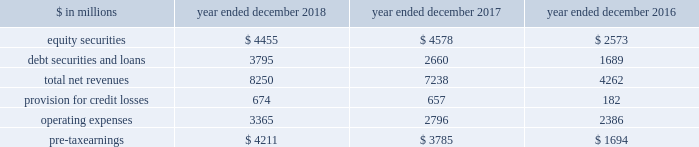The goldman sachs group , inc .
And subsidiaries management 2019s discussion and analysis net revenues in equities were $ 6.60 billion , 4% ( 4 % ) lower than 2016 , primarily due to lower commissions and fees , reflecting a decline in our listed cash equity volumes in the u.s .
Market volumes in the u.s .
Also declined .
In addition , net revenues in equities client execution were lower , reflecting lower net revenues in derivatives , partially offset by higher net revenues in cash products .
Net revenues in securities services were essentially unchanged .
Operating expenses were $ 9.69 billion for 2017 , essentially unchanged compared with 2016 , due to decreased compensation and benefits expenses , reflecting lower net revenues , largely offset by increased technology expenses , reflecting higher expenses related to cloud-based services and software depreciation , and increased consulting costs .
Pre-tax earnings were $ 2.21 billion in 2017 , 54% ( 54 % ) lower than 2016 .
Investing & lending investing & lending includes our investing activities and the origination of loans , including our relationship lending activities , to provide financing to clients .
These investments and loans are typically longer-term in nature .
We make investments , some of which are consolidated , including through our merchant banking business and our special situations group , in debt securities and loans , public and private equity securities , infrastructure and real estate entities .
Some of these investments are made indirectly through funds that we manage .
We also make unsecured loans through our digital platform , marcus : by goldman sachs and secured loans through our digital platform , goldman sachs private bank select .
The table below presents the operating results of our investing & lending segment. .
Operating environment .
During 2018 , our investments in private equities benefited from company-specific events , including sales , and strong corporate performance , while investments in public equities reflected losses , as global equity prices generally decreased .
Results for our investments in debt securities and loans reflected continued growth in loans receivables , resulting in higher net interest income .
If macroeconomic concerns negatively affect corporate performance or the origination of loans , or if global equity prices continue to decline , net revenues in investing & lending would likely be negatively impacted .
During 2017 , generally higher global equity prices and tighter credit spreads contributed to a favorable environment for our equity and debt investments .
Results also reflected net gains from company-specific events , including sales , and corporate performance .
2018 versus 2017 .
Net revenues in investing & lending were $ 8.25 billion for 2018 , 14% ( 14 % ) higher than 2017 .
Net revenues in equity securities were $ 4.46 billion , 3% ( 3 % ) lower than 2017 , reflecting net losses from investments in public equities ( 2018 included $ 183 million of net losses ) compared with net gains in the prior year , partially offset by significantly higher net gains from investments in private equities ( 2018 included $ 4.64 billion of net gains ) , driven by company-specific events , including sales , and corporate performance .
For 2018 , 60% ( 60 % ) of the net revenues in equity securities were generated from corporate investments and 40% ( 40 % ) were generated from real estate .
Net revenues in debt securities and loans were $ 3.80 billion , 43% ( 43 % ) higher than 2017 , primarily driven by significantly higher net interest income .
2018 included net interest income of approximately $ 2.70 billion compared with approximately $ 1.80 billion in 2017 .
Provision for credit losses was $ 674 million for 2018 , compared with $ 657 million for 2017 , as the higher provision for credit losses primarily related to consumer loan growth in 2018 was partially offset by an impairment of approximately $ 130 million on a secured loan in 2017 .
Operating expenses were $ 3.37 billion for 2018 , 20% ( 20 % ) higher than 2017 , primarily due to increased expenses related to consolidated investments and our digital lending and deposit platform , and increased compensation and benefits expenses , reflecting higher net revenues .
Pre-tax earnings were $ 4.21 billion in 2018 , 11% ( 11 % ) higher than 2017 versus 2016 .
Net revenues in investing & lending were $ 7.24 billion for 2017 , 70% ( 70 % ) higher than 2016 .
Net revenues in equity securities were $ 4.58 billion , 78% ( 78 % ) higher than 2016 , primarily reflecting a significant increase in net gains from private equities ( 2017 included $ 3.82 billion of net gains ) , which were positively impacted by company-specific events and corporate performance .
In addition , net gains from public equities ( 2017 included $ 762 million of net gains ) were significantly higher , as global equity prices increased during the year .
For 2017 , 64% ( 64 % ) of the net revenues in equity securities were generated from corporate investments and 36% ( 36 % ) were generated from real estate .
Net revenues in debt securities and loans were $ 2.66 billion , 57% ( 57 % ) higher than 2016 , reflecting significantly higher net interest income ( 2017 included approximately $ 1.80 billion of net interest income ) .
60 goldman sachs 2018 form 10-k .
For the lending segment , in millions , for 2018 , 2017 , and 2016 , what was the largest earnings from equity securities? 
Computations: table_max(equity securities, none)
Answer: 4578.0. The goldman sachs group , inc .
And subsidiaries management 2019s discussion and analysis net revenues in equities were $ 6.60 billion , 4% ( 4 % ) lower than 2016 , primarily due to lower commissions and fees , reflecting a decline in our listed cash equity volumes in the u.s .
Market volumes in the u.s .
Also declined .
In addition , net revenues in equities client execution were lower , reflecting lower net revenues in derivatives , partially offset by higher net revenues in cash products .
Net revenues in securities services were essentially unchanged .
Operating expenses were $ 9.69 billion for 2017 , essentially unchanged compared with 2016 , due to decreased compensation and benefits expenses , reflecting lower net revenues , largely offset by increased technology expenses , reflecting higher expenses related to cloud-based services and software depreciation , and increased consulting costs .
Pre-tax earnings were $ 2.21 billion in 2017 , 54% ( 54 % ) lower than 2016 .
Investing & lending investing & lending includes our investing activities and the origination of loans , including our relationship lending activities , to provide financing to clients .
These investments and loans are typically longer-term in nature .
We make investments , some of which are consolidated , including through our merchant banking business and our special situations group , in debt securities and loans , public and private equity securities , infrastructure and real estate entities .
Some of these investments are made indirectly through funds that we manage .
We also make unsecured loans through our digital platform , marcus : by goldman sachs and secured loans through our digital platform , goldman sachs private bank select .
The table below presents the operating results of our investing & lending segment. .
Operating environment .
During 2018 , our investments in private equities benefited from company-specific events , including sales , and strong corporate performance , while investments in public equities reflected losses , as global equity prices generally decreased .
Results for our investments in debt securities and loans reflected continued growth in loans receivables , resulting in higher net interest income .
If macroeconomic concerns negatively affect corporate performance or the origination of loans , or if global equity prices continue to decline , net revenues in investing & lending would likely be negatively impacted .
During 2017 , generally higher global equity prices and tighter credit spreads contributed to a favorable environment for our equity and debt investments .
Results also reflected net gains from company-specific events , including sales , and corporate performance .
2018 versus 2017 .
Net revenues in investing & lending were $ 8.25 billion for 2018 , 14% ( 14 % ) higher than 2017 .
Net revenues in equity securities were $ 4.46 billion , 3% ( 3 % ) lower than 2017 , reflecting net losses from investments in public equities ( 2018 included $ 183 million of net losses ) compared with net gains in the prior year , partially offset by significantly higher net gains from investments in private equities ( 2018 included $ 4.64 billion of net gains ) , driven by company-specific events , including sales , and corporate performance .
For 2018 , 60% ( 60 % ) of the net revenues in equity securities were generated from corporate investments and 40% ( 40 % ) were generated from real estate .
Net revenues in debt securities and loans were $ 3.80 billion , 43% ( 43 % ) higher than 2017 , primarily driven by significantly higher net interest income .
2018 included net interest income of approximately $ 2.70 billion compared with approximately $ 1.80 billion in 2017 .
Provision for credit losses was $ 674 million for 2018 , compared with $ 657 million for 2017 , as the higher provision for credit losses primarily related to consumer loan growth in 2018 was partially offset by an impairment of approximately $ 130 million on a secured loan in 2017 .
Operating expenses were $ 3.37 billion for 2018 , 20% ( 20 % ) higher than 2017 , primarily due to increased expenses related to consolidated investments and our digital lending and deposit platform , and increased compensation and benefits expenses , reflecting higher net revenues .
Pre-tax earnings were $ 4.21 billion in 2018 , 11% ( 11 % ) higher than 2017 versus 2016 .
Net revenues in investing & lending were $ 7.24 billion for 2017 , 70% ( 70 % ) higher than 2016 .
Net revenues in equity securities were $ 4.58 billion , 78% ( 78 % ) higher than 2016 , primarily reflecting a significant increase in net gains from private equities ( 2017 included $ 3.82 billion of net gains ) , which were positively impacted by company-specific events and corporate performance .
In addition , net gains from public equities ( 2017 included $ 762 million of net gains ) were significantly higher , as global equity prices increased during the year .
For 2017 , 64% ( 64 % ) of the net revenues in equity securities were generated from corporate investments and 36% ( 36 % ) were generated from real estate .
Net revenues in debt securities and loans were $ 2.66 billion , 57% ( 57 % ) higher than 2016 , reflecting significantly higher net interest income ( 2017 included approximately $ 1.80 billion of net interest income ) .
60 goldman sachs 2018 form 10-k .
What is the growth rate in total net revenue in 2018? 
Computations: ((8250 - 7238) / 7238)
Answer: 0.13982. 